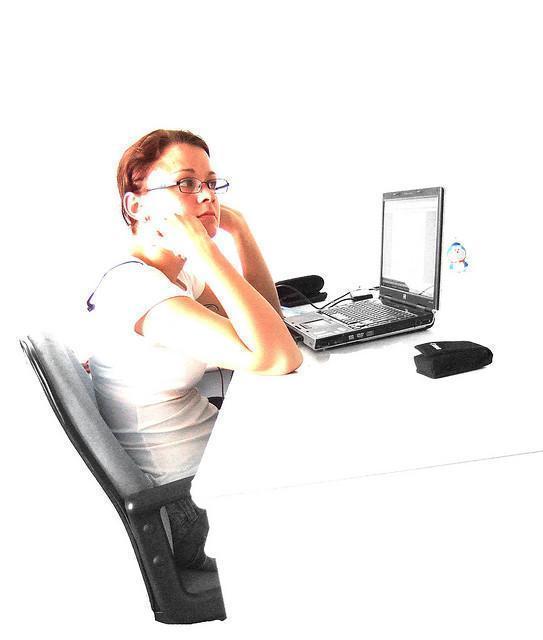Why is the woman sitting down?
Indicate the correct response by choosing from the four available options to answer the question.
Options: To paint, to work, to sew, to eat. To work. 